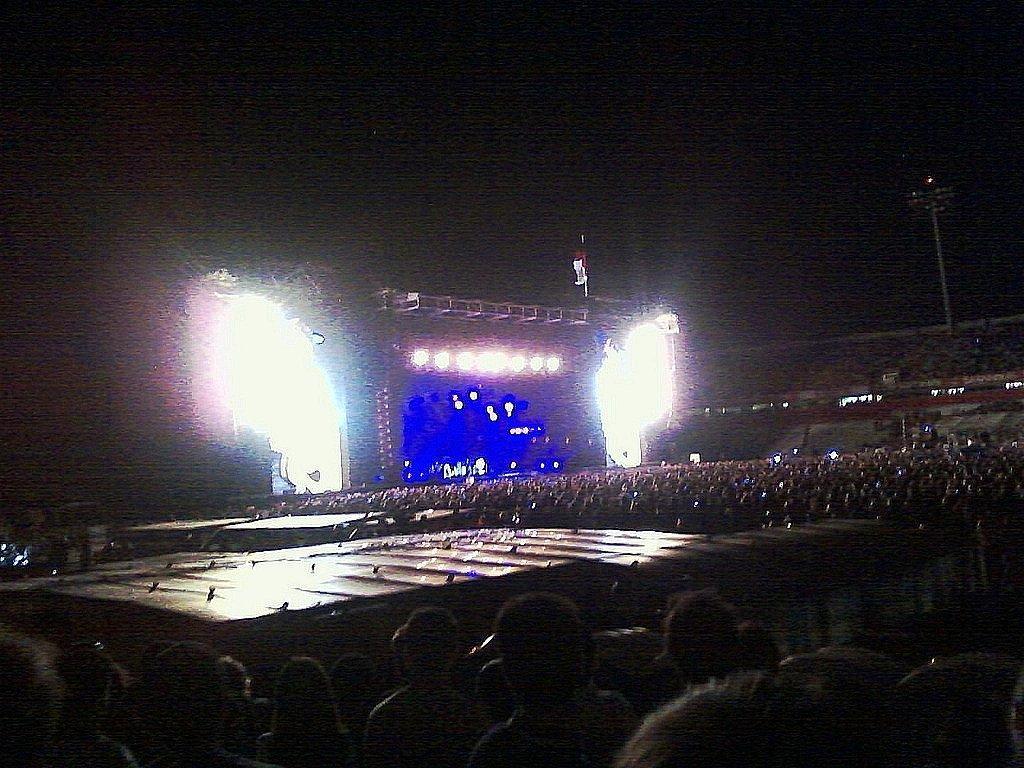How would you summarize this image in a sentence or two? In this picture we can see some people, in the background there is a screen and some lights, on the right side there is a pole, we can see a dark background. 